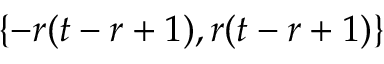Convert formula to latex. <formula><loc_0><loc_0><loc_500><loc_500>\{ - r ( t - r + 1 ) , r ( t - r + 1 ) \}</formula> 